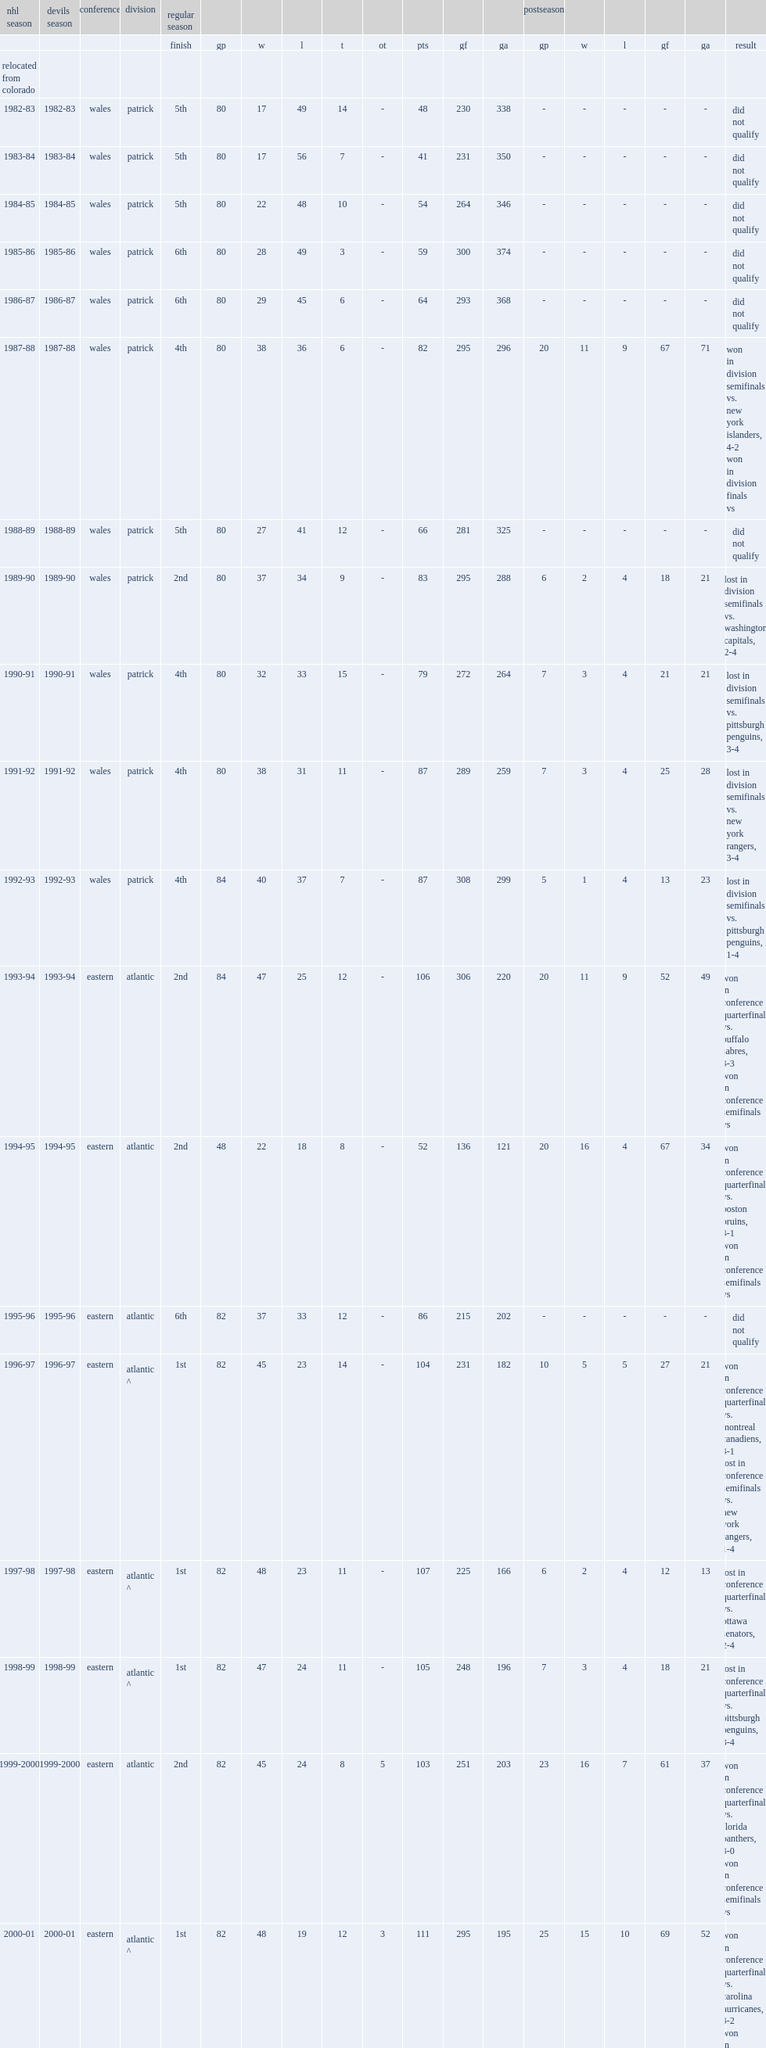How many seasons are there before the 1995-96 new jersey devils season? 14. 